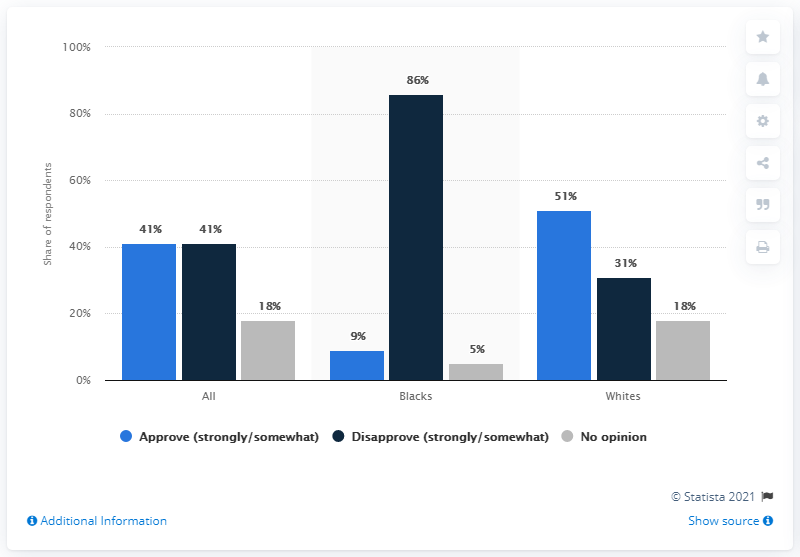Indicate a few pertinent items in this graphic. According to the survey, 86% of Black respondents disapprove of the jury's verdict. 